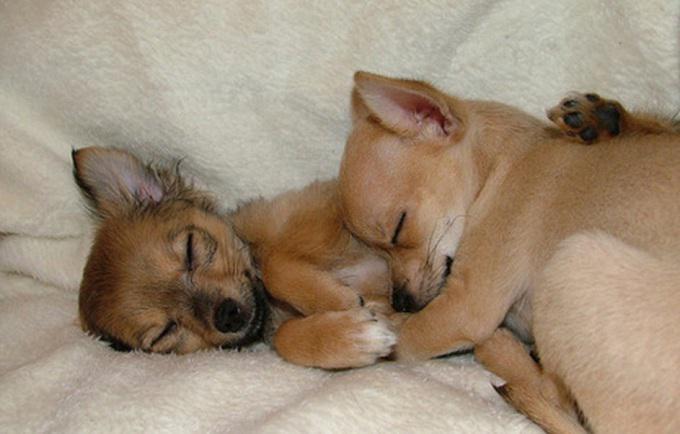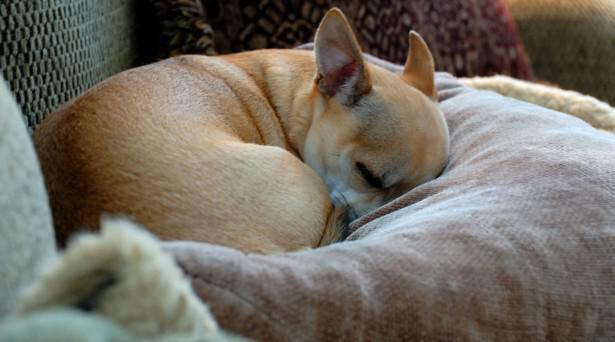The first image is the image on the left, the second image is the image on the right. Analyze the images presented: Is the assertion "All chihuahuas appear to be sleeping, and one image contains twice as many chihuahuas as the other image." valid? Answer yes or no. Yes. The first image is the image on the left, the second image is the image on the right. For the images displayed, is the sentence "Three dogs are lying down sleeping." factually correct? Answer yes or no. Yes. 